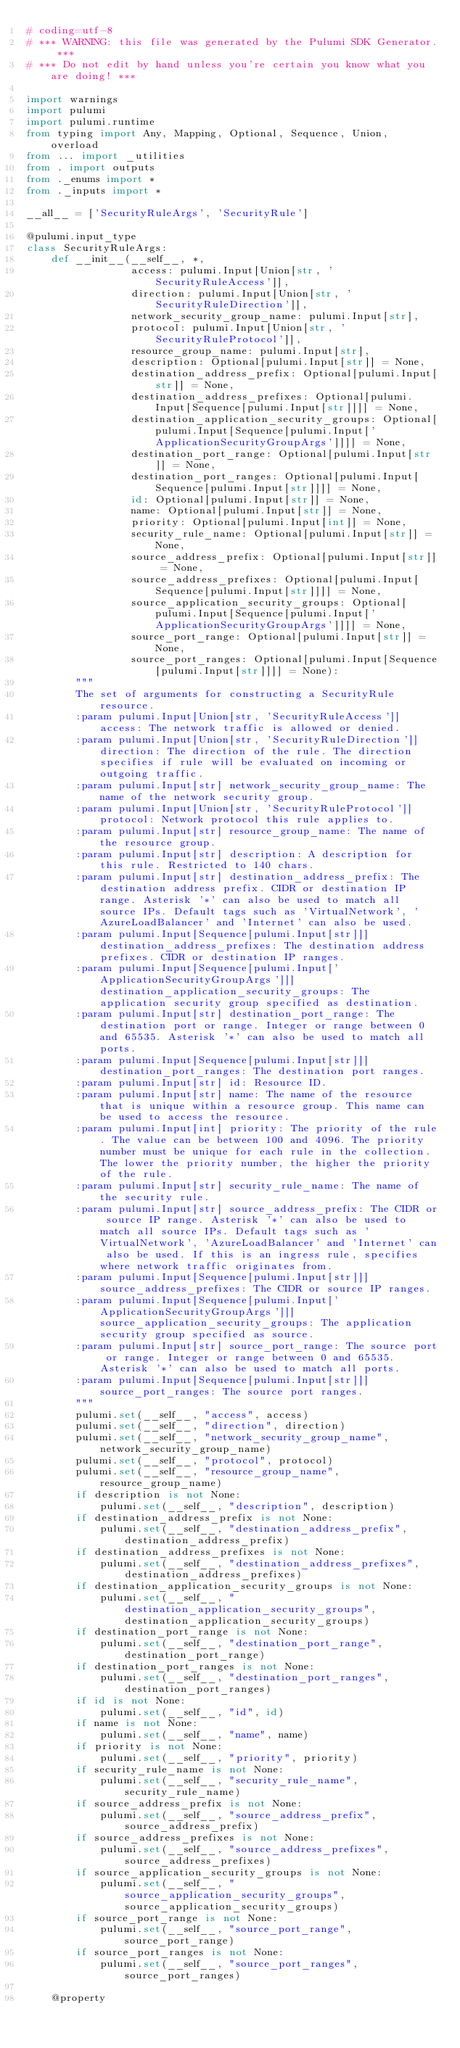Convert code to text. <code><loc_0><loc_0><loc_500><loc_500><_Python_># coding=utf-8
# *** WARNING: this file was generated by the Pulumi SDK Generator. ***
# *** Do not edit by hand unless you're certain you know what you are doing! ***

import warnings
import pulumi
import pulumi.runtime
from typing import Any, Mapping, Optional, Sequence, Union, overload
from ... import _utilities
from . import outputs
from ._enums import *
from ._inputs import *

__all__ = ['SecurityRuleArgs', 'SecurityRule']

@pulumi.input_type
class SecurityRuleArgs:
    def __init__(__self__, *,
                 access: pulumi.Input[Union[str, 'SecurityRuleAccess']],
                 direction: pulumi.Input[Union[str, 'SecurityRuleDirection']],
                 network_security_group_name: pulumi.Input[str],
                 protocol: pulumi.Input[Union[str, 'SecurityRuleProtocol']],
                 resource_group_name: pulumi.Input[str],
                 description: Optional[pulumi.Input[str]] = None,
                 destination_address_prefix: Optional[pulumi.Input[str]] = None,
                 destination_address_prefixes: Optional[pulumi.Input[Sequence[pulumi.Input[str]]]] = None,
                 destination_application_security_groups: Optional[pulumi.Input[Sequence[pulumi.Input['ApplicationSecurityGroupArgs']]]] = None,
                 destination_port_range: Optional[pulumi.Input[str]] = None,
                 destination_port_ranges: Optional[pulumi.Input[Sequence[pulumi.Input[str]]]] = None,
                 id: Optional[pulumi.Input[str]] = None,
                 name: Optional[pulumi.Input[str]] = None,
                 priority: Optional[pulumi.Input[int]] = None,
                 security_rule_name: Optional[pulumi.Input[str]] = None,
                 source_address_prefix: Optional[pulumi.Input[str]] = None,
                 source_address_prefixes: Optional[pulumi.Input[Sequence[pulumi.Input[str]]]] = None,
                 source_application_security_groups: Optional[pulumi.Input[Sequence[pulumi.Input['ApplicationSecurityGroupArgs']]]] = None,
                 source_port_range: Optional[pulumi.Input[str]] = None,
                 source_port_ranges: Optional[pulumi.Input[Sequence[pulumi.Input[str]]]] = None):
        """
        The set of arguments for constructing a SecurityRule resource.
        :param pulumi.Input[Union[str, 'SecurityRuleAccess']] access: The network traffic is allowed or denied.
        :param pulumi.Input[Union[str, 'SecurityRuleDirection']] direction: The direction of the rule. The direction specifies if rule will be evaluated on incoming or outgoing traffic.
        :param pulumi.Input[str] network_security_group_name: The name of the network security group.
        :param pulumi.Input[Union[str, 'SecurityRuleProtocol']] protocol: Network protocol this rule applies to.
        :param pulumi.Input[str] resource_group_name: The name of the resource group.
        :param pulumi.Input[str] description: A description for this rule. Restricted to 140 chars.
        :param pulumi.Input[str] destination_address_prefix: The destination address prefix. CIDR or destination IP range. Asterisk '*' can also be used to match all source IPs. Default tags such as 'VirtualNetwork', 'AzureLoadBalancer' and 'Internet' can also be used.
        :param pulumi.Input[Sequence[pulumi.Input[str]]] destination_address_prefixes: The destination address prefixes. CIDR or destination IP ranges.
        :param pulumi.Input[Sequence[pulumi.Input['ApplicationSecurityGroupArgs']]] destination_application_security_groups: The application security group specified as destination.
        :param pulumi.Input[str] destination_port_range: The destination port or range. Integer or range between 0 and 65535. Asterisk '*' can also be used to match all ports.
        :param pulumi.Input[Sequence[pulumi.Input[str]]] destination_port_ranges: The destination port ranges.
        :param pulumi.Input[str] id: Resource ID.
        :param pulumi.Input[str] name: The name of the resource that is unique within a resource group. This name can be used to access the resource.
        :param pulumi.Input[int] priority: The priority of the rule. The value can be between 100 and 4096. The priority number must be unique for each rule in the collection. The lower the priority number, the higher the priority of the rule.
        :param pulumi.Input[str] security_rule_name: The name of the security rule.
        :param pulumi.Input[str] source_address_prefix: The CIDR or source IP range. Asterisk '*' can also be used to match all source IPs. Default tags such as 'VirtualNetwork', 'AzureLoadBalancer' and 'Internet' can also be used. If this is an ingress rule, specifies where network traffic originates from.
        :param pulumi.Input[Sequence[pulumi.Input[str]]] source_address_prefixes: The CIDR or source IP ranges.
        :param pulumi.Input[Sequence[pulumi.Input['ApplicationSecurityGroupArgs']]] source_application_security_groups: The application security group specified as source.
        :param pulumi.Input[str] source_port_range: The source port or range. Integer or range between 0 and 65535. Asterisk '*' can also be used to match all ports.
        :param pulumi.Input[Sequence[pulumi.Input[str]]] source_port_ranges: The source port ranges.
        """
        pulumi.set(__self__, "access", access)
        pulumi.set(__self__, "direction", direction)
        pulumi.set(__self__, "network_security_group_name", network_security_group_name)
        pulumi.set(__self__, "protocol", protocol)
        pulumi.set(__self__, "resource_group_name", resource_group_name)
        if description is not None:
            pulumi.set(__self__, "description", description)
        if destination_address_prefix is not None:
            pulumi.set(__self__, "destination_address_prefix", destination_address_prefix)
        if destination_address_prefixes is not None:
            pulumi.set(__self__, "destination_address_prefixes", destination_address_prefixes)
        if destination_application_security_groups is not None:
            pulumi.set(__self__, "destination_application_security_groups", destination_application_security_groups)
        if destination_port_range is not None:
            pulumi.set(__self__, "destination_port_range", destination_port_range)
        if destination_port_ranges is not None:
            pulumi.set(__self__, "destination_port_ranges", destination_port_ranges)
        if id is not None:
            pulumi.set(__self__, "id", id)
        if name is not None:
            pulumi.set(__self__, "name", name)
        if priority is not None:
            pulumi.set(__self__, "priority", priority)
        if security_rule_name is not None:
            pulumi.set(__self__, "security_rule_name", security_rule_name)
        if source_address_prefix is not None:
            pulumi.set(__self__, "source_address_prefix", source_address_prefix)
        if source_address_prefixes is not None:
            pulumi.set(__self__, "source_address_prefixes", source_address_prefixes)
        if source_application_security_groups is not None:
            pulumi.set(__self__, "source_application_security_groups", source_application_security_groups)
        if source_port_range is not None:
            pulumi.set(__self__, "source_port_range", source_port_range)
        if source_port_ranges is not None:
            pulumi.set(__self__, "source_port_ranges", source_port_ranges)

    @property</code> 